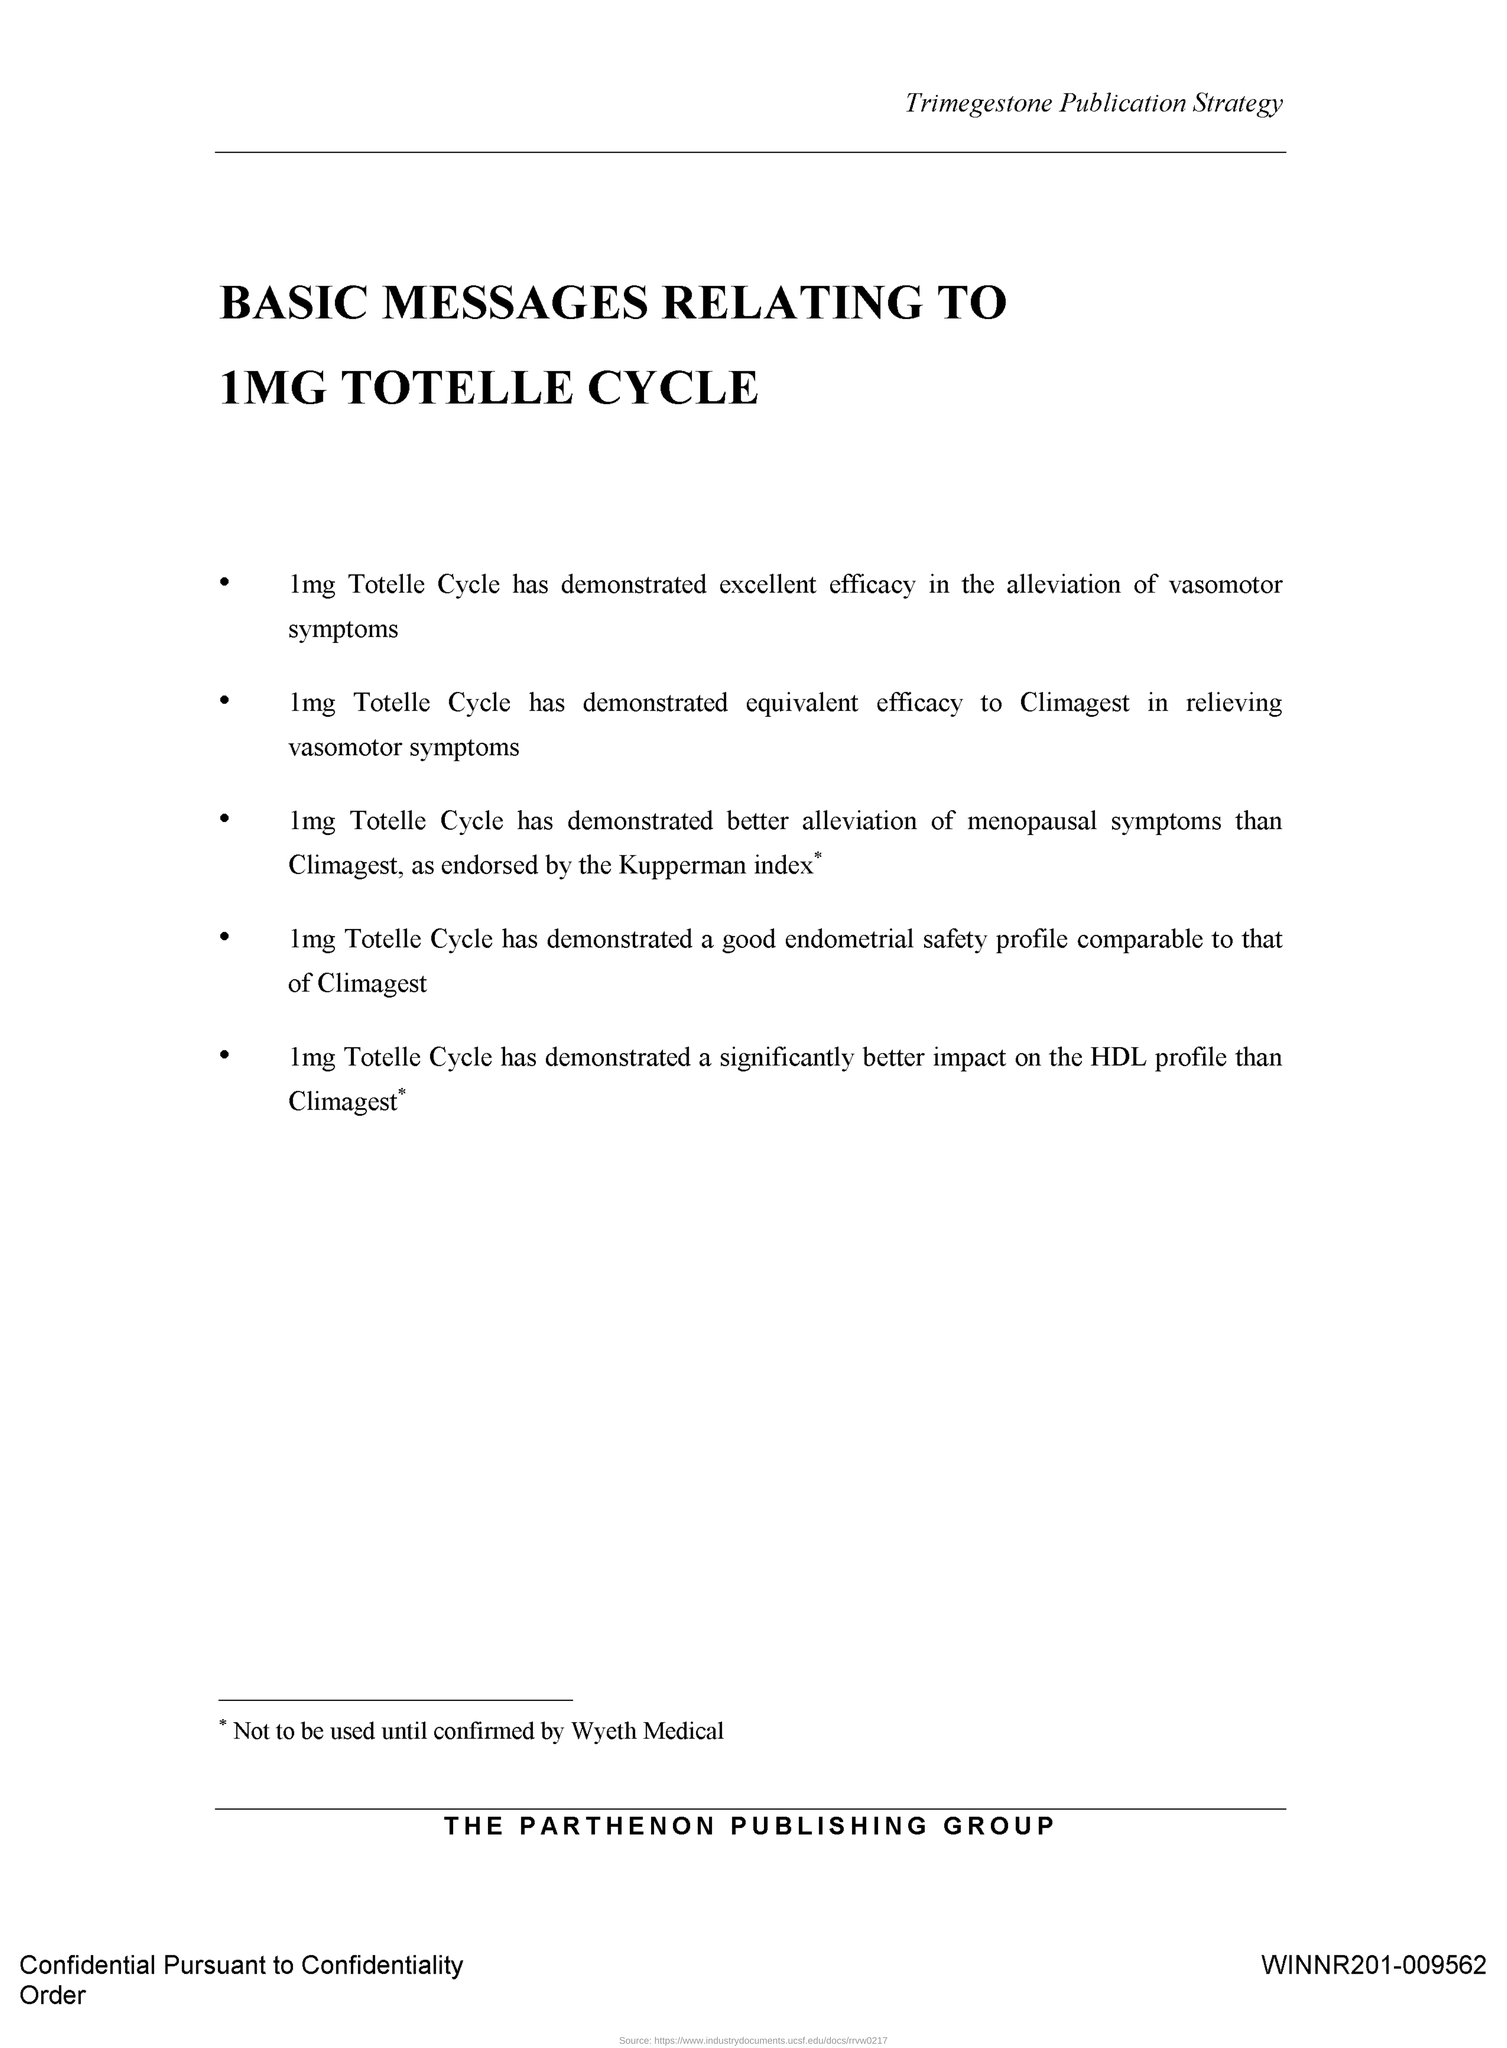Highlight a few significant elements in this photo. The title of the document is 'Basic Messages relating to 1mg totelle cycle.' 